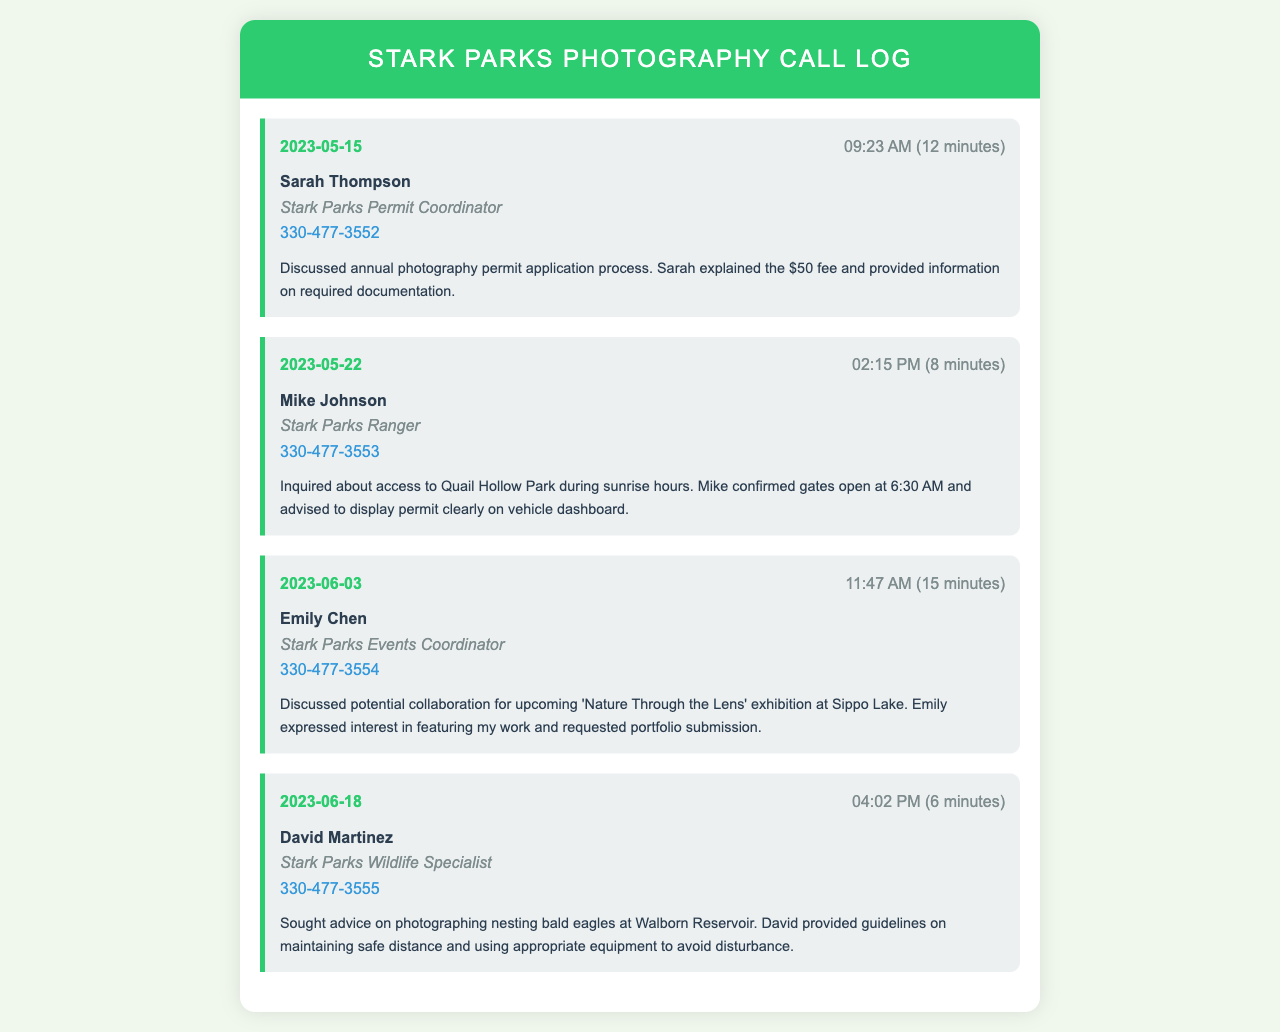What is the date of the first call? The first call is dated May 15, 2023, which is the earliest entry in the call log.
Answer: May 15, 2023 Who did I speak with about the annual photography permit? The entry indicates that I spoke with Sarah Thompson regarding the permit application process.
Answer: Sarah Thompson What is the title of Emily Chen? The document states that Emily Chen is the Events Coordinator for Stark Parks.
Answer: Events Coordinator What information was provided during the call with Mike Johnson? The notes summarize that Mike Johnson confirmed the opening time for Quail Hollow Park and advised on permit display.
Answer: Gates open at 6:30 AM How long did the call with David Martinez last? The entry notes that the call with David Martinez lasted for 6 minutes.
Answer: 6 minutes What was the main topic of discussion in the call with Emily Chen? The call discussed a potential collaboration for the 'Nature Through the Lens' exhibition and a request for portfolio submission.
Answer: Exhibition collaboration How many calls involved inquiries about photography permits? By reviewing the entries, I find there are two calls specifically focused on photography permits.
Answer: Two calls What is the phone number for the Stark Parks Ranger? The document lists Mike Johnson's phone number as 330-477-3553, who is identified as the Ranger.
Answer: 330-477-3553 